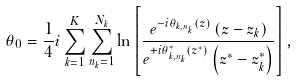<formula> <loc_0><loc_0><loc_500><loc_500>\theta _ { 0 } = \frac { 1 } { 4 } i \sum _ { k = 1 } ^ { K } \sum _ { n _ { k } = 1 } ^ { N _ { k } } \ln \left [ \frac { e ^ { - i \theta _ { k , n _ { k } } ( z ) } \left ( z - z _ { k } \right ) } { e ^ { + i \theta ^ { * } _ { k , n _ { k } } ( z ^ { * } ) } \left ( z ^ { * } - z ^ { * } _ { k } \right ) } \right ] ,</formula> 